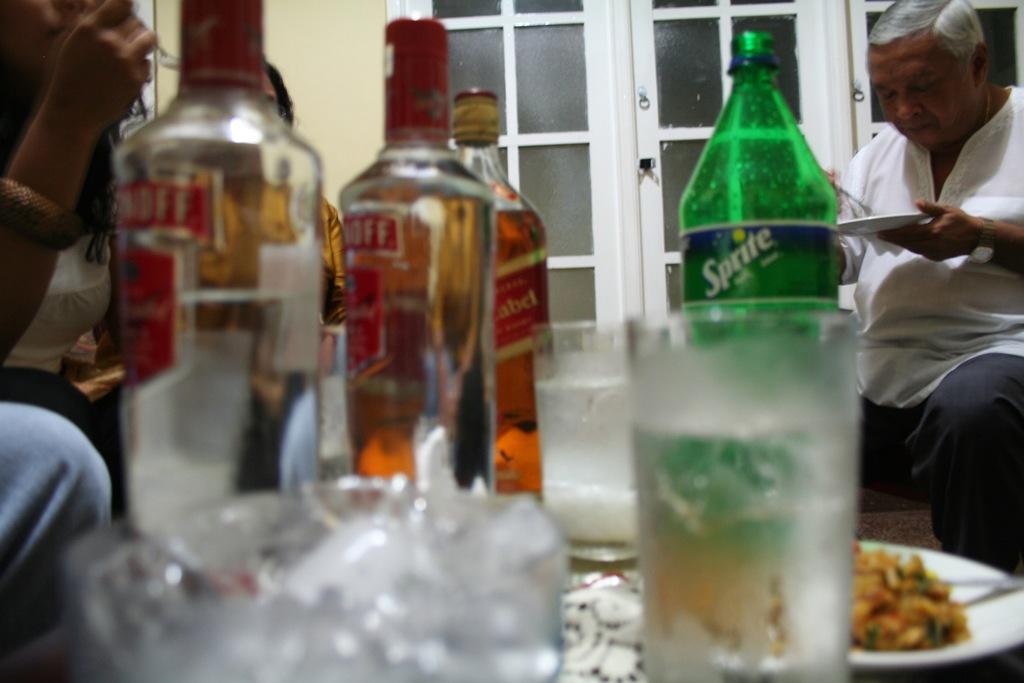What kind of liquor is that?
Your answer should be very brief. Smirnoff vodka. 